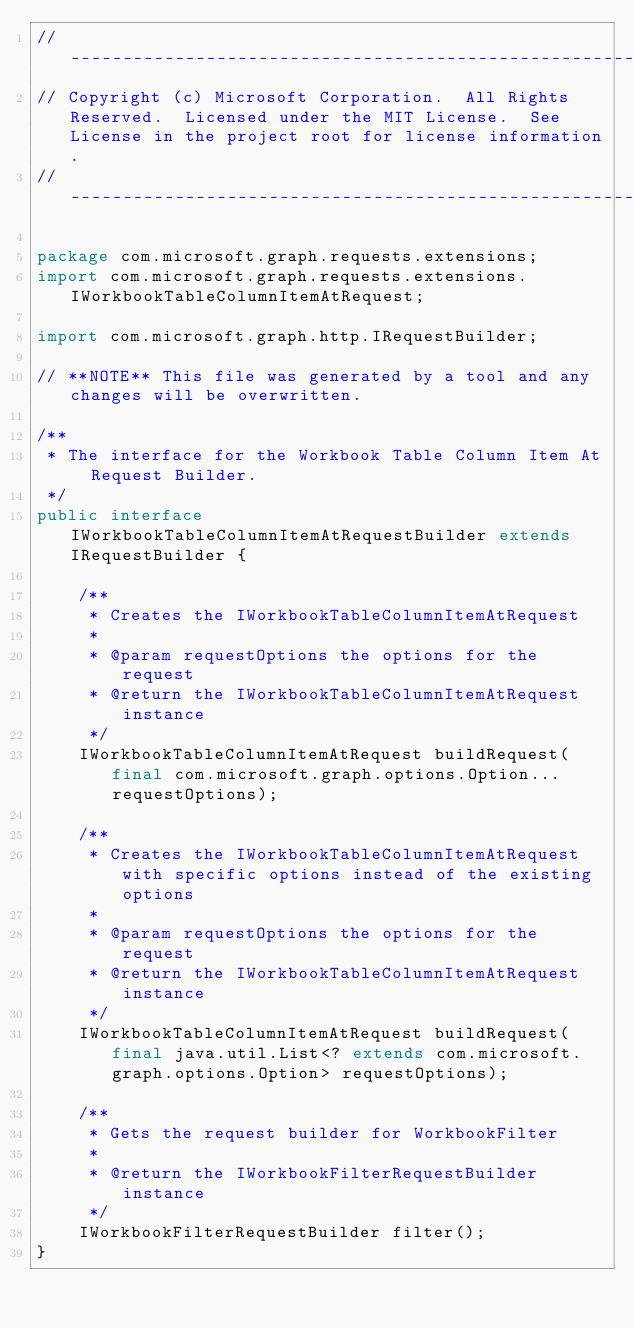Convert code to text. <code><loc_0><loc_0><loc_500><loc_500><_Java_>// ------------------------------------------------------------------------------
// Copyright (c) Microsoft Corporation.  All Rights Reserved.  Licensed under the MIT License.  See License in the project root for license information.
// ------------------------------------------------------------------------------

package com.microsoft.graph.requests.extensions;
import com.microsoft.graph.requests.extensions.IWorkbookTableColumnItemAtRequest;

import com.microsoft.graph.http.IRequestBuilder;

// **NOTE** This file was generated by a tool and any changes will be overwritten.

/**
 * The interface for the Workbook Table Column Item At Request Builder.
 */
public interface IWorkbookTableColumnItemAtRequestBuilder extends IRequestBuilder {

    /**
     * Creates the IWorkbookTableColumnItemAtRequest
     *
     * @param requestOptions the options for the request
     * @return the IWorkbookTableColumnItemAtRequest instance
     */
    IWorkbookTableColumnItemAtRequest buildRequest(final com.microsoft.graph.options.Option... requestOptions);

    /**
     * Creates the IWorkbookTableColumnItemAtRequest with specific options instead of the existing options
     *
     * @param requestOptions the options for the request
     * @return the IWorkbookTableColumnItemAtRequest instance
     */
    IWorkbookTableColumnItemAtRequest buildRequest(final java.util.List<? extends com.microsoft.graph.options.Option> requestOptions);

    /**
     * Gets the request builder for WorkbookFilter
     *
     * @return the IWorkbookFilterRequestBuilder instance
     */
    IWorkbookFilterRequestBuilder filter();
}
</code> 